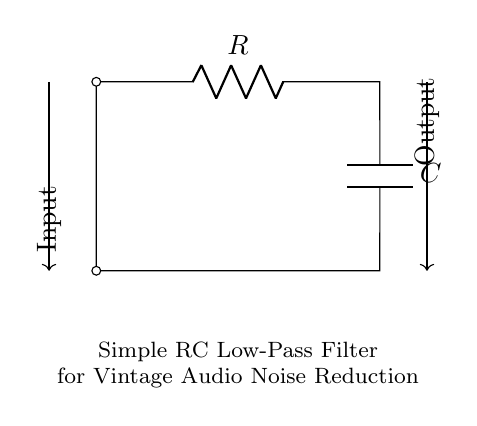What is the type of filter represented in this circuit? The circuit is a low-pass filter, which allows low-frequency signals to pass while attenuating high-frequency noise. This is evident from the placement of the resistor and capacitor, where the output is taken across the capacitor.
Answer: low-pass filter What components are used in this RC circuit? The circuit includes a resistor (labeled R) and a capacitor (labeled C). These components are essential for forming the RC filtering effect, where the resistor limits the current and the capacitor stores charge.
Answer: resistor and capacitor Where is the input and output labeled in the circuit? The input is labeled on the left side, and the output is labeled on the right side of the circuit diagram, with arrows indicating the direction of the signals. This setup shows how the signal enters the circuit and exits after passing through the filter.
Answer: left side for input, right side for output What happens to high-frequency noise in this circuit? In a low-pass RC filter, high-frequency noise is reduced because the reactance of the capacitor increases with frequency, leading to more attenuation of high-frequency signals compared to low-frequency signals. Thus, the filter effectively smoothes out noise.
Answer: reduced or attenuated What is the primary purpose of this RC filter in vintage audio equipment? The primary purpose is to reduce noise in audio signals, ensuring a clearer sound reproduction by filtering out unwanted high-frequency interference that may distort the sound quality of historical recordings.
Answer: reduce noise 